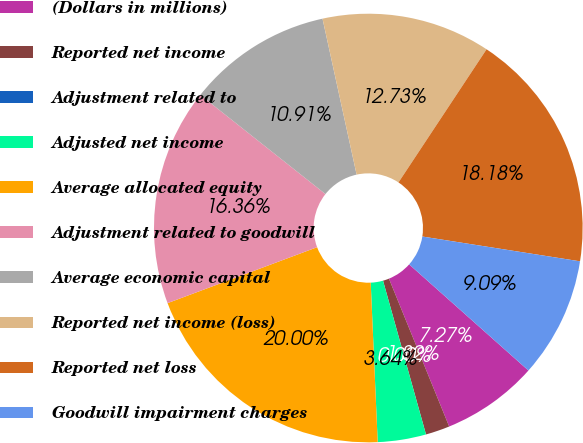Convert chart to OTSL. <chart><loc_0><loc_0><loc_500><loc_500><pie_chart><fcel>(Dollars in millions)<fcel>Reported net income<fcel>Adjustment related to<fcel>Adjusted net income<fcel>Average allocated equity<fcel>Adjustment related to goodwill<fcel>Average economic capital<fcel>Reported net income (loss)<fcel>Reported net loss<fcel>Goodwill impairment charges<nl><fcel>7.27%<fcel>1.82%<fcel>0.0%<fcel>3.64%<fcel>20.0%<fcel>16.36%<fcel>10.91%<fcel>12.73%<fcel>18.18%<fcel>9.09%<nl></chart> 